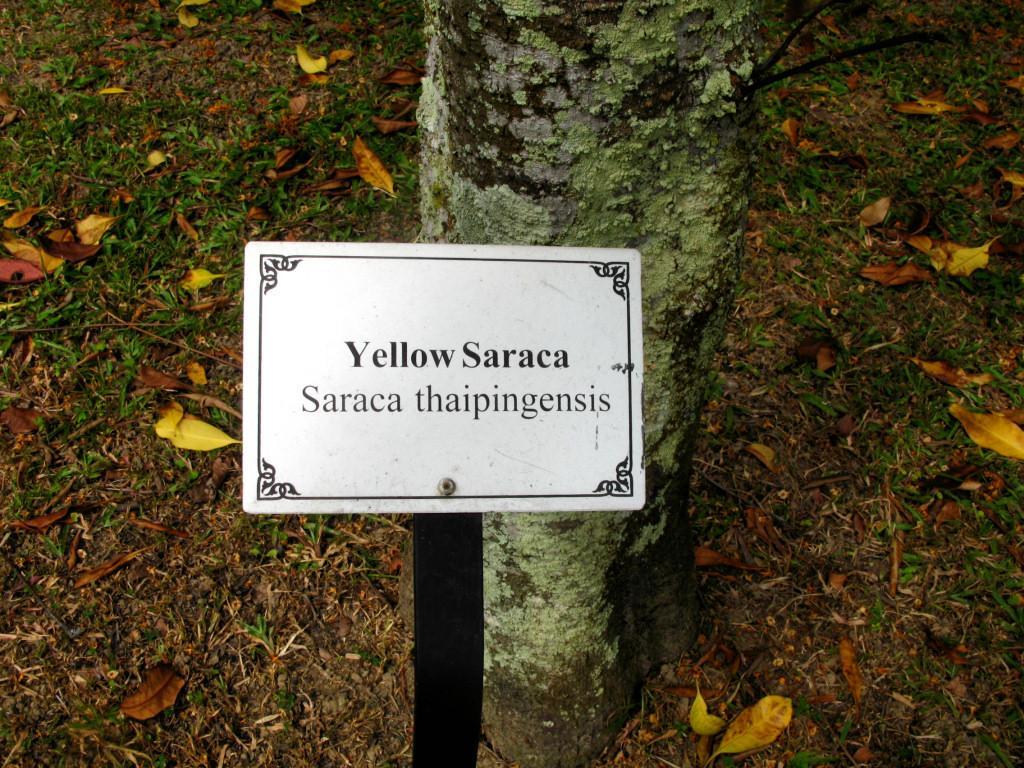In one or two sentences, can you explain what this image depicts? In the picture I can see a yellow color board on which we can see some text is fixed to the pole, here I can see tree trunk and dried leaves on the grass ground. 